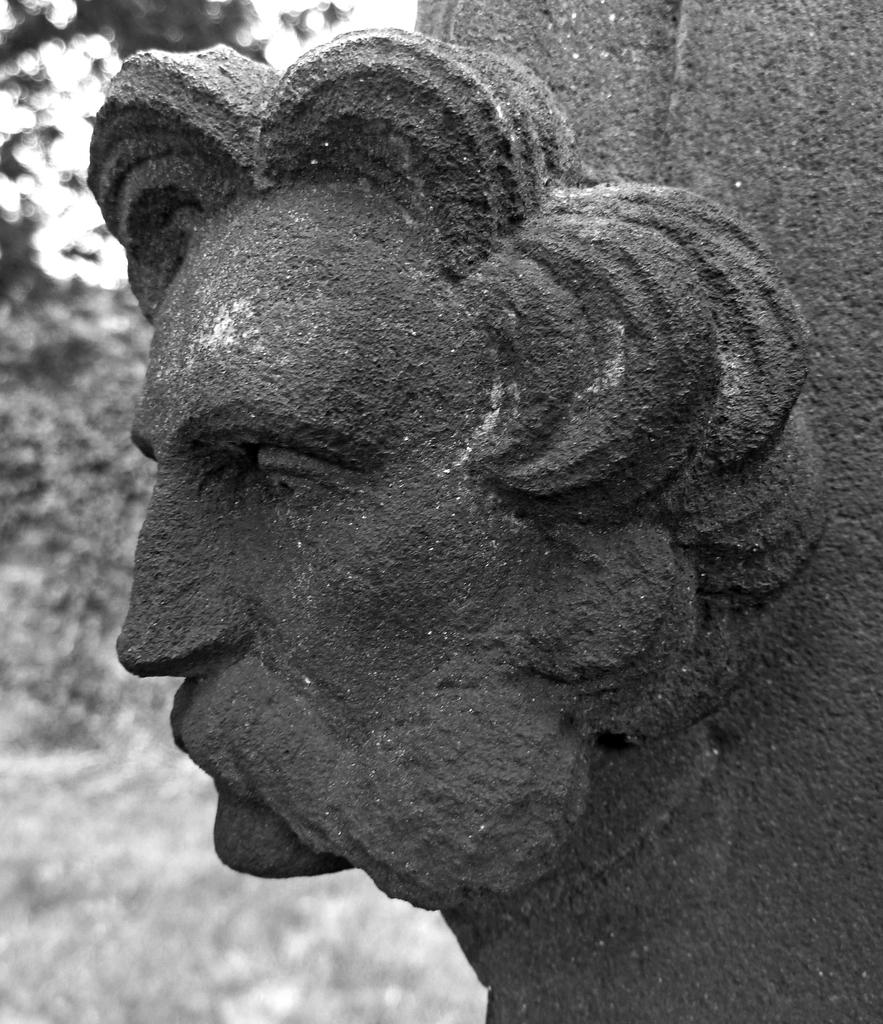What is the main subject of the image? There is a sculpture in the image. What can be seen in the background of the image? There are trees in the background of the image. What is visible at the bottom of the image? The ground is visible at the bottom of the image. What is the color scheme of the image? The image is black and white. How many clocks are hanging from the branches of the trees in the image? There are no clocks visible in the image; it features a sculpture and trees in a black and white color scheme. Can you see any animals on the farm in the image? There is no farm present in the image; it features a sculpture, trees, and a black and white color scheme. 